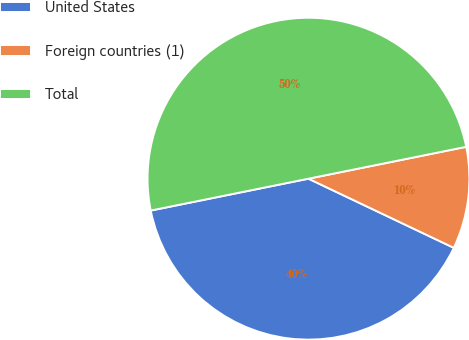Convert chart. <chart><loc_0><loc_0><loc_500><loc_500><pie_chart><fcel>United States<fcel>Foreign countries (1)<fcel>Total<nl><fcel>39.76%<fcel>10.24%<fcel>50.0%<nl></chart> 